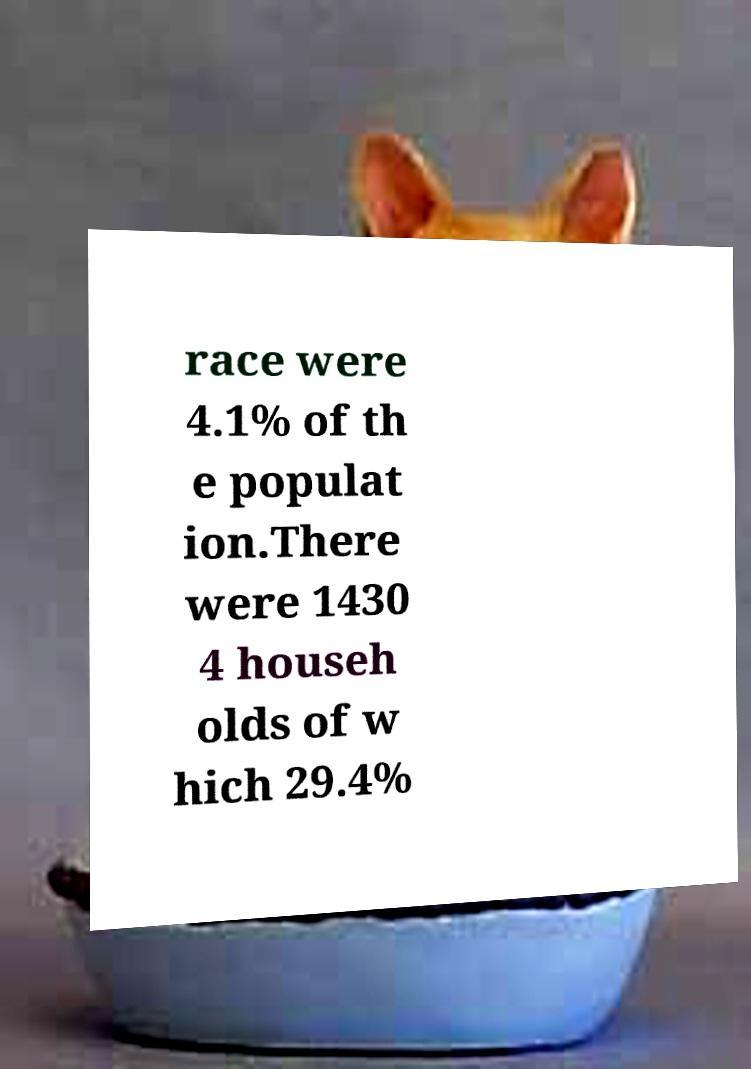Please identify and transcribe the text found in this image. race were 4.1% of th e populat ion.There were 1430 4 househ olds of w hich 29.4% 